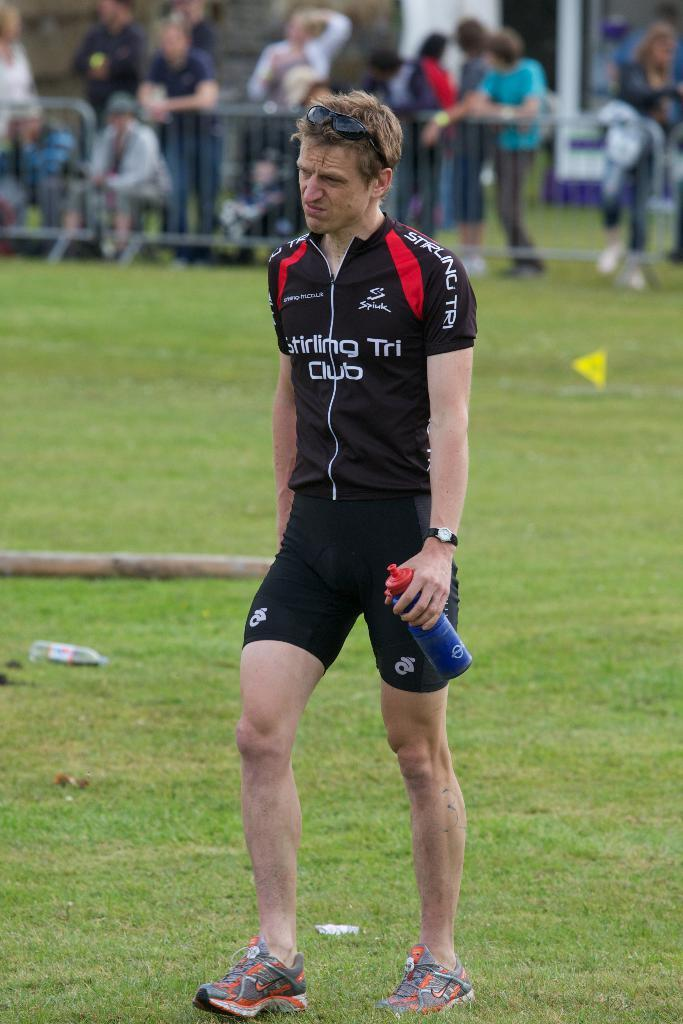Provide a one-sentence caption for the provided image. Man holding a water bottle while wearing a shirt that says "Stirling Tri Club". 